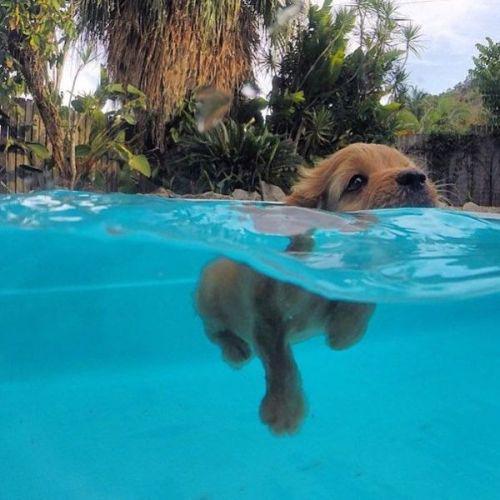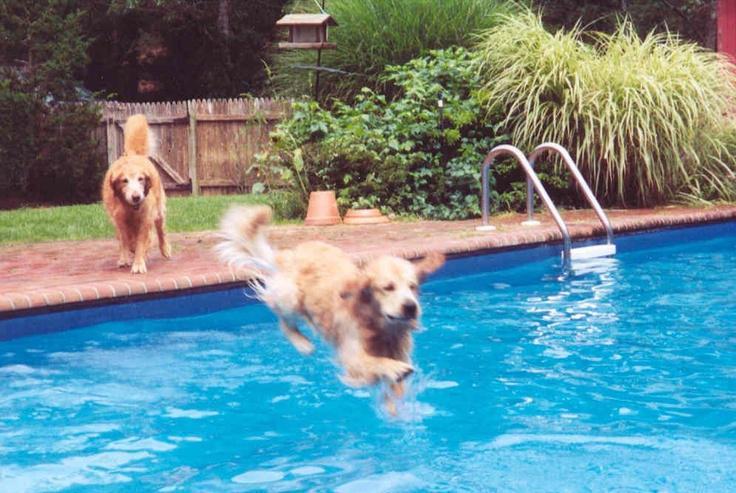The first image is the image on the left, the second image is the image on the right. For the images displayed, is the sentence "A dog is in mid-leap over the blue water of a manmade pool." factually correct? Answer yes or no. Yes. The first image is the image on the left, the second image is the image on the right. Analyze the images presented: Is the assertion "One of the dogs is using a floatation device in the pool." valid? Answer yes or no. No. 